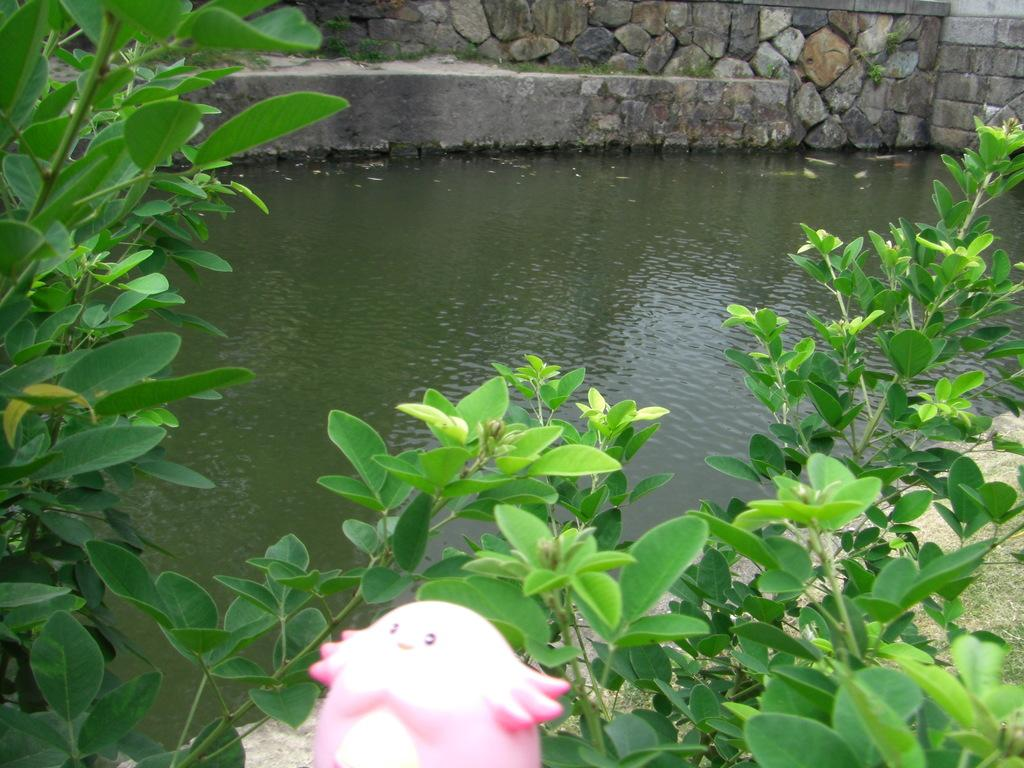What is visible in the image? Water is visible in the image. What type of vegetation is present on the sides of the image? There are plants on the sides of the image. What type of structure can be seen in the image? There is a brick wall in the image. What type of object is pink and present in the image? There is a pink color toy in the image. What type of debt is being discussed in the image? There is no mention or indication of any debt in the image. What type of chalk is being used to draw on the brick wall in the image? There is no chalk or drawing present on the brick wall in the image. 